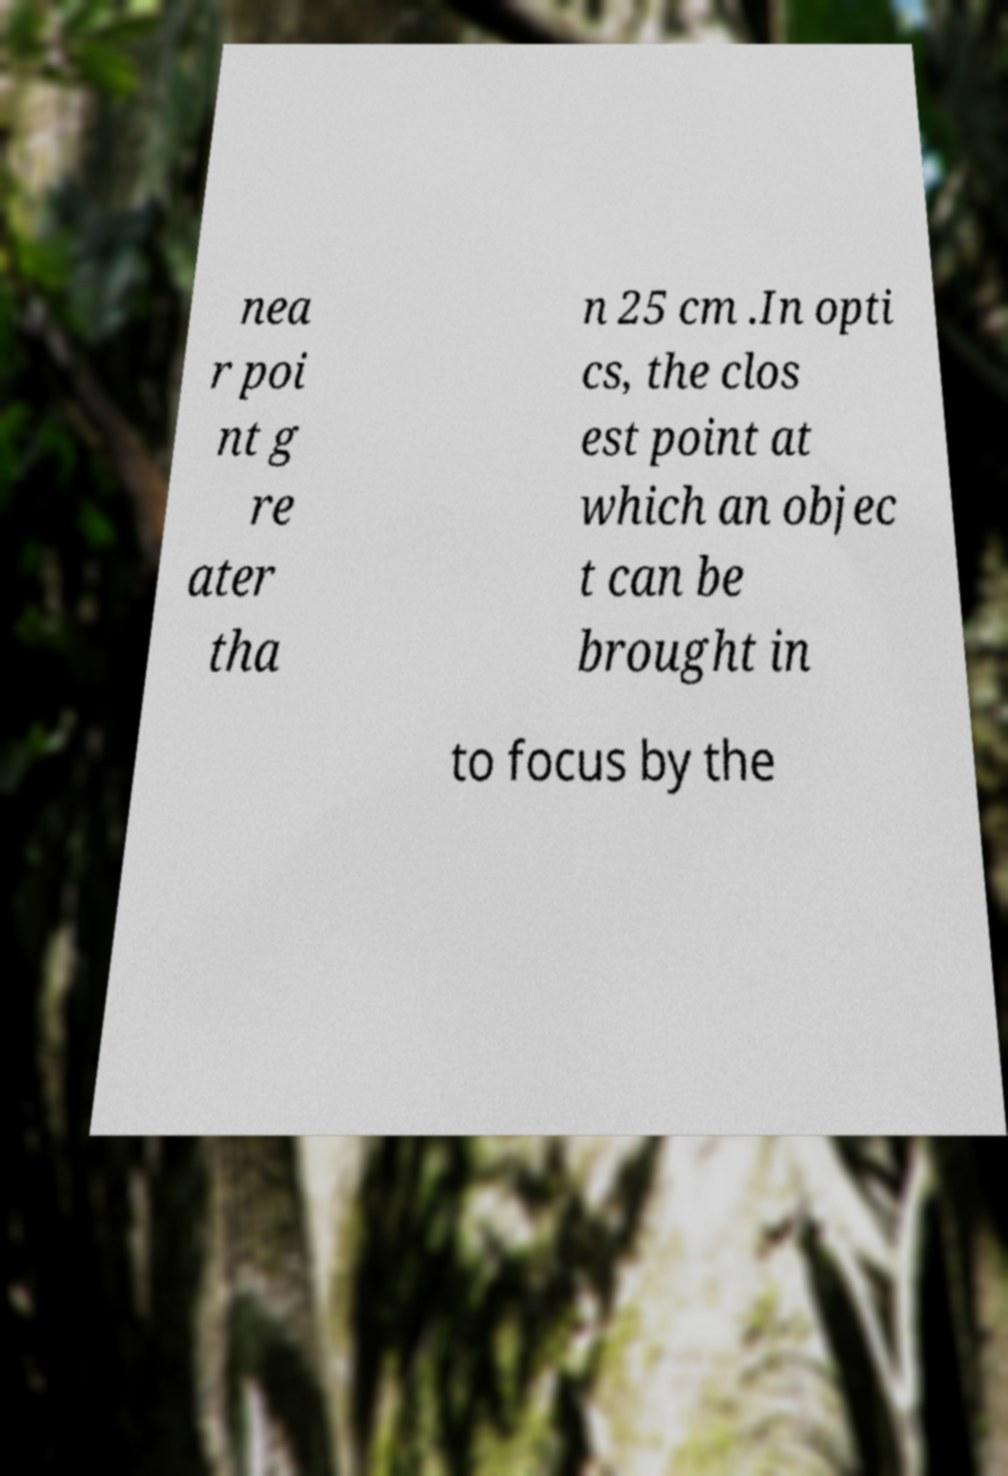Can you read and provide the text displayed in the image?This photo seems to have some interesting text. Can you extract and type it out for me? nea r poi nt g re ater tha n 25 cm .In opti cs, the clos est point at which an objec t can be brought in to focus by the 